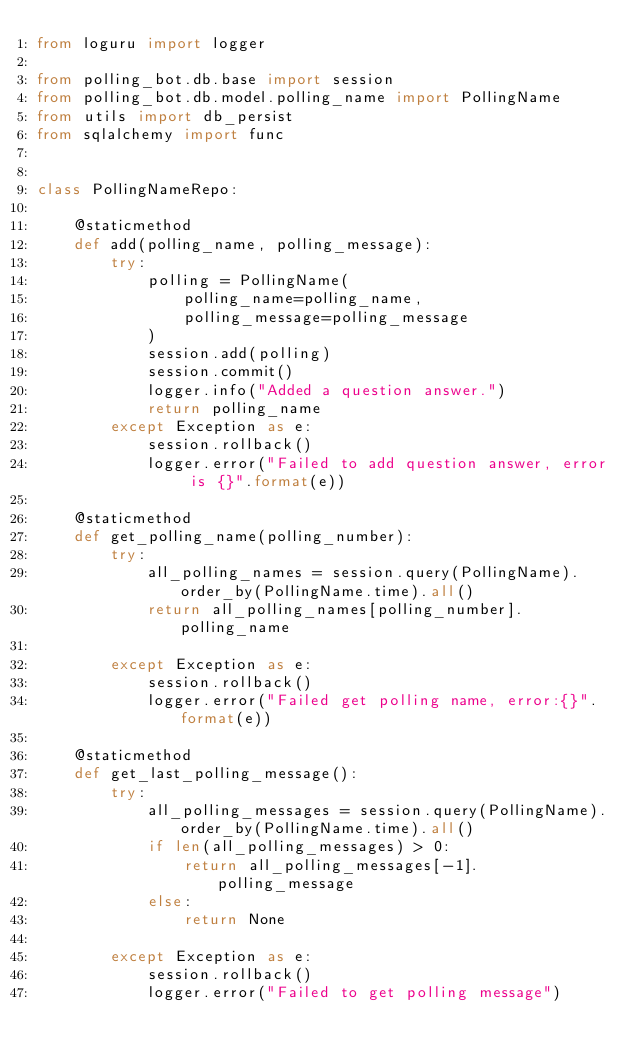Convert code to text. <code><loc_0><loc_0><loc_500><loc_500><_Python_>from loguru import logger

from polling_bot.db.base import session
from polling_bot.db.model.polling_name import PollingName
from utils import db_persist
from sqlalchemy import func


class PollingNameRepo:

    @staticmethod
    def add(polling_name, polling_message):
        try:
            polling = PollingName(
                polling_name=polling_name,
                polling_message=polling_message
            )
            session.add(polling)
            session.commit()
            logger.info("Added a question answer.")
            return polling_name
        except Exception as e:
            session.rollback()
            logger.error("Failed to add question answer, error is {}".format(e))

    @staticmethod
    def get_polling_name(polling_number):
        try:
            all_polling_names = session.query(PollingName).order_by(PollingName.time).all()
            return all_polling_names[polling_number].polling_name

        except Exception as e:
            session.rollback()
            logger.error("Failed get polling name, error:{}".format(e))

    @staticmethod
    def get_last_polling_message():
        try:
            all_polling_messages = session.query(PollingName).order_by(PollingName.time).all()
            if len(all_polling_messages) > 0:
                return all_polling_messages[-1].polling_message
            else:
                return None

        except Exception as e:
            session.rollback()
            logger.error("Failed to get polling message")

</code> 